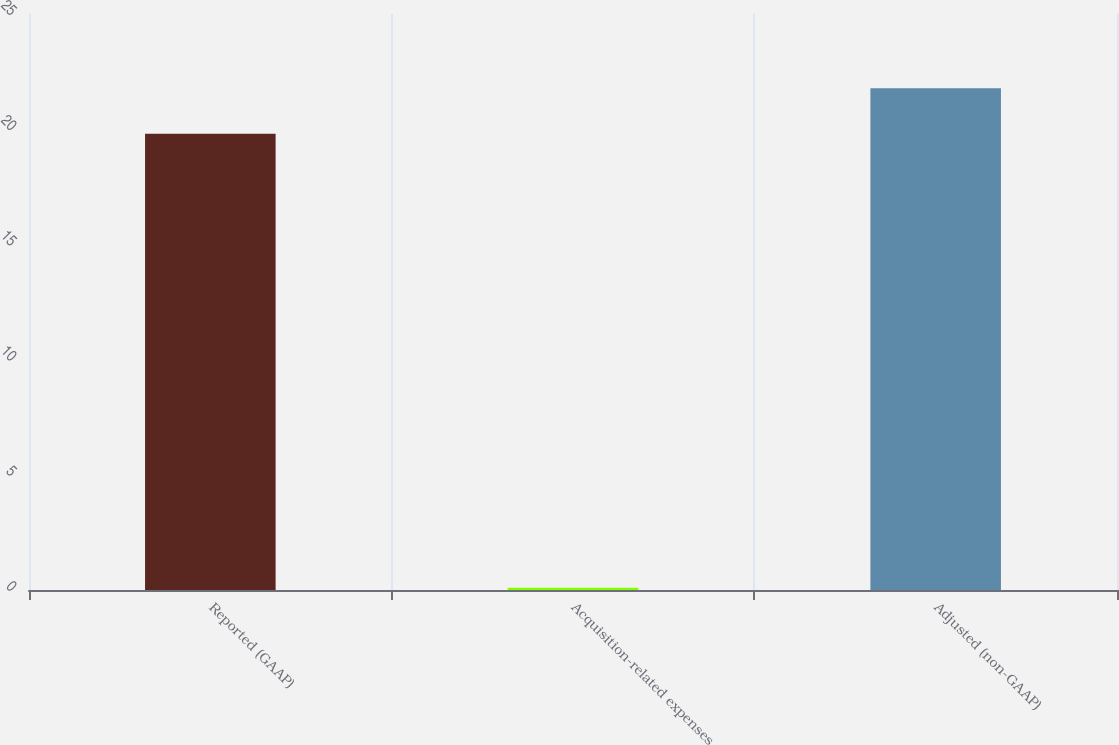<chart> <loc_0><loc_0><loc_500><loc_500><bar_chart><fcel>Reported (GAAP)<fcel>Acquisition-related expenses<fcel>Adjusted (non-GAAP)<nl><fcel>19.8<fcel>0.1<fcel>21.78<nl></chart> 